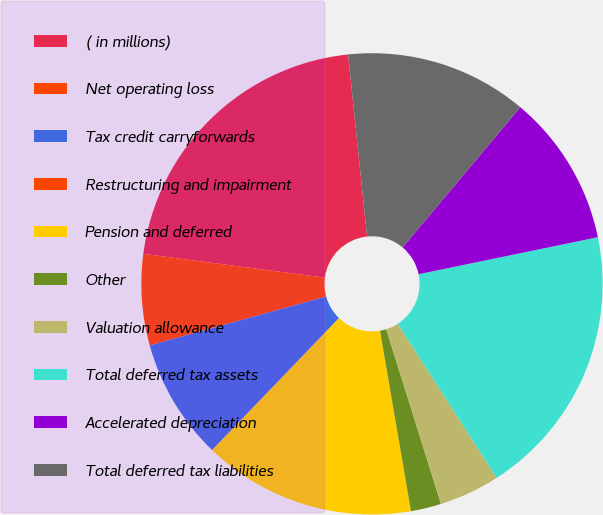Convert chart. <chart><loc_0><loc_0><loc_500><loc_500><pie_chart><fcel>( in millions)<fcel>Net operating loss<fcel>Tax credit carryforwards<fcel>Restructuring and impairment<fcel>Pension and deferred<fcel>Other<fcel>Valuation allowance<fcel>Total deferred tax assets<fcel>Accelerated depreciation<fcel>Total deferred tax liabilities<nl><fcel>21.27%<fcel>6.38%<fcel>8.51%<fcel>0.0%<fcel>14.89%<fcel>2.13%<fcel>4.26%<fcel>19.15%<fcel>10.64%<fcel>12.77%<nl></chart> 